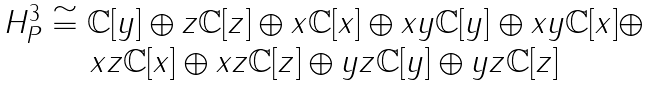<formula> <loc_0><loc_0><loc_500><loc_500>\begin{array} { c c c } H ^ { 3 } _ { P } \cong \mathbb { C } [ y ] \oplus z \mathbb { C } [ z ] \oplus x \mathbb { C } [ x ] \oplus x y \mathbb { C } [ y ] \oplus x y \mathbb { C } [ x ] \oplus \\ x z \mathbb { C } [ x ] \oplus x z \mathbb { C } [ z ] \oplus y z \mathbb { C } [ y ] \oplus y z \mathbb { C } [ z ] \end{array}</formula> 